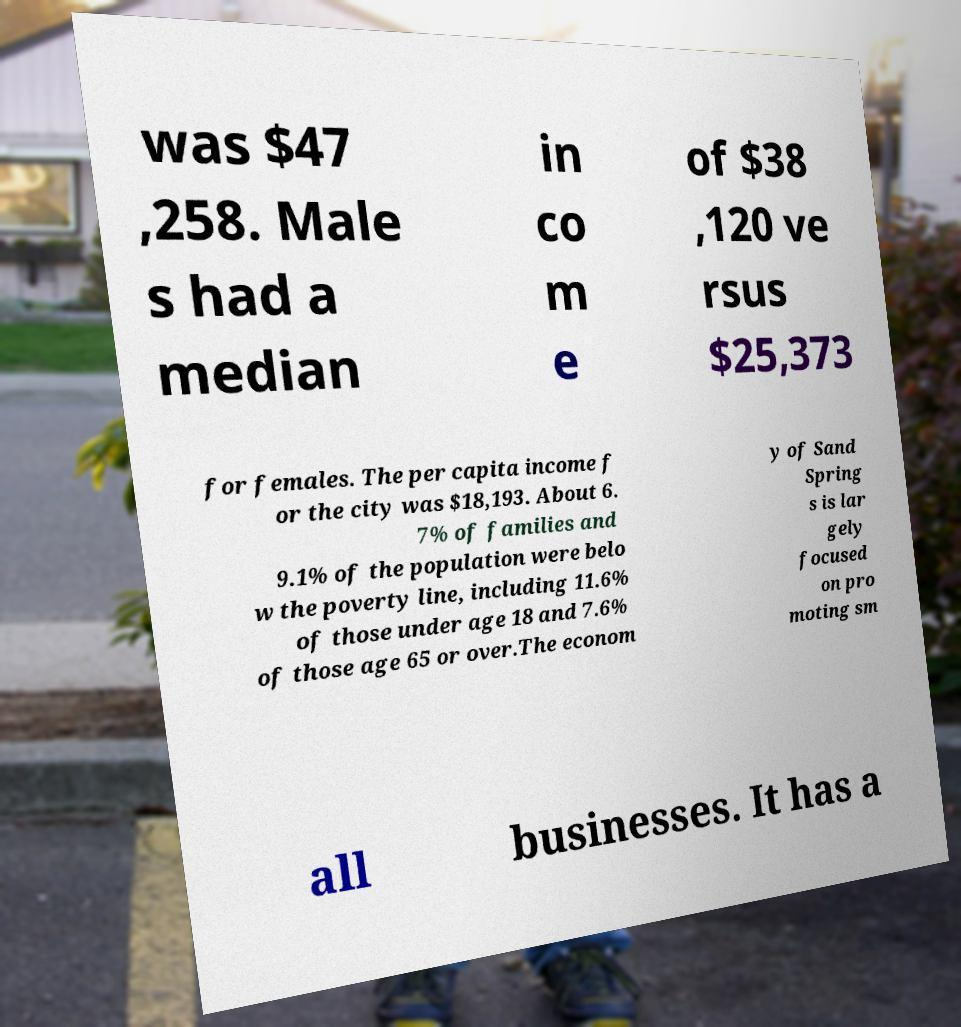I need the written content from this picture converted into text. Can you do that? was $47 ,258. Male s had a median in co m e of $38 ,120 ve rsus $25,373 for females. The per capita income f or the city was $18,193. About 6. 7% of families and 9.1% of the population were belo w the poverty line, including 11.6% of those under age 18 and 7.6% of those age 65 or over.The econom y of Sand Spring s is lar gely focused on pro moting sm all businesses. It has a 